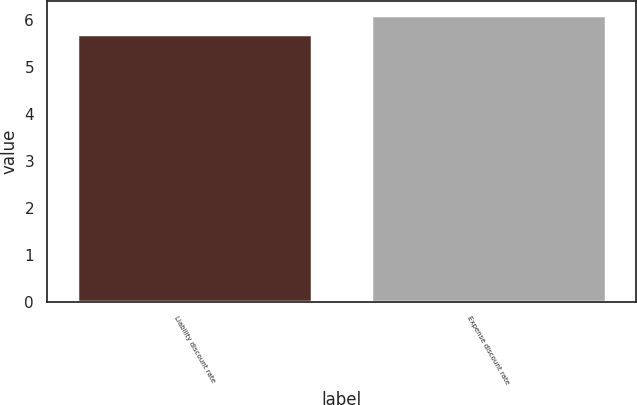<chart> <loc_0><loc_0><loc_500><loc_500><bar_chart><fcel>Liability discount rate<fcel>Expense discount rate<nl><fcel>5.7<fcel>6.1<nl></chart> 